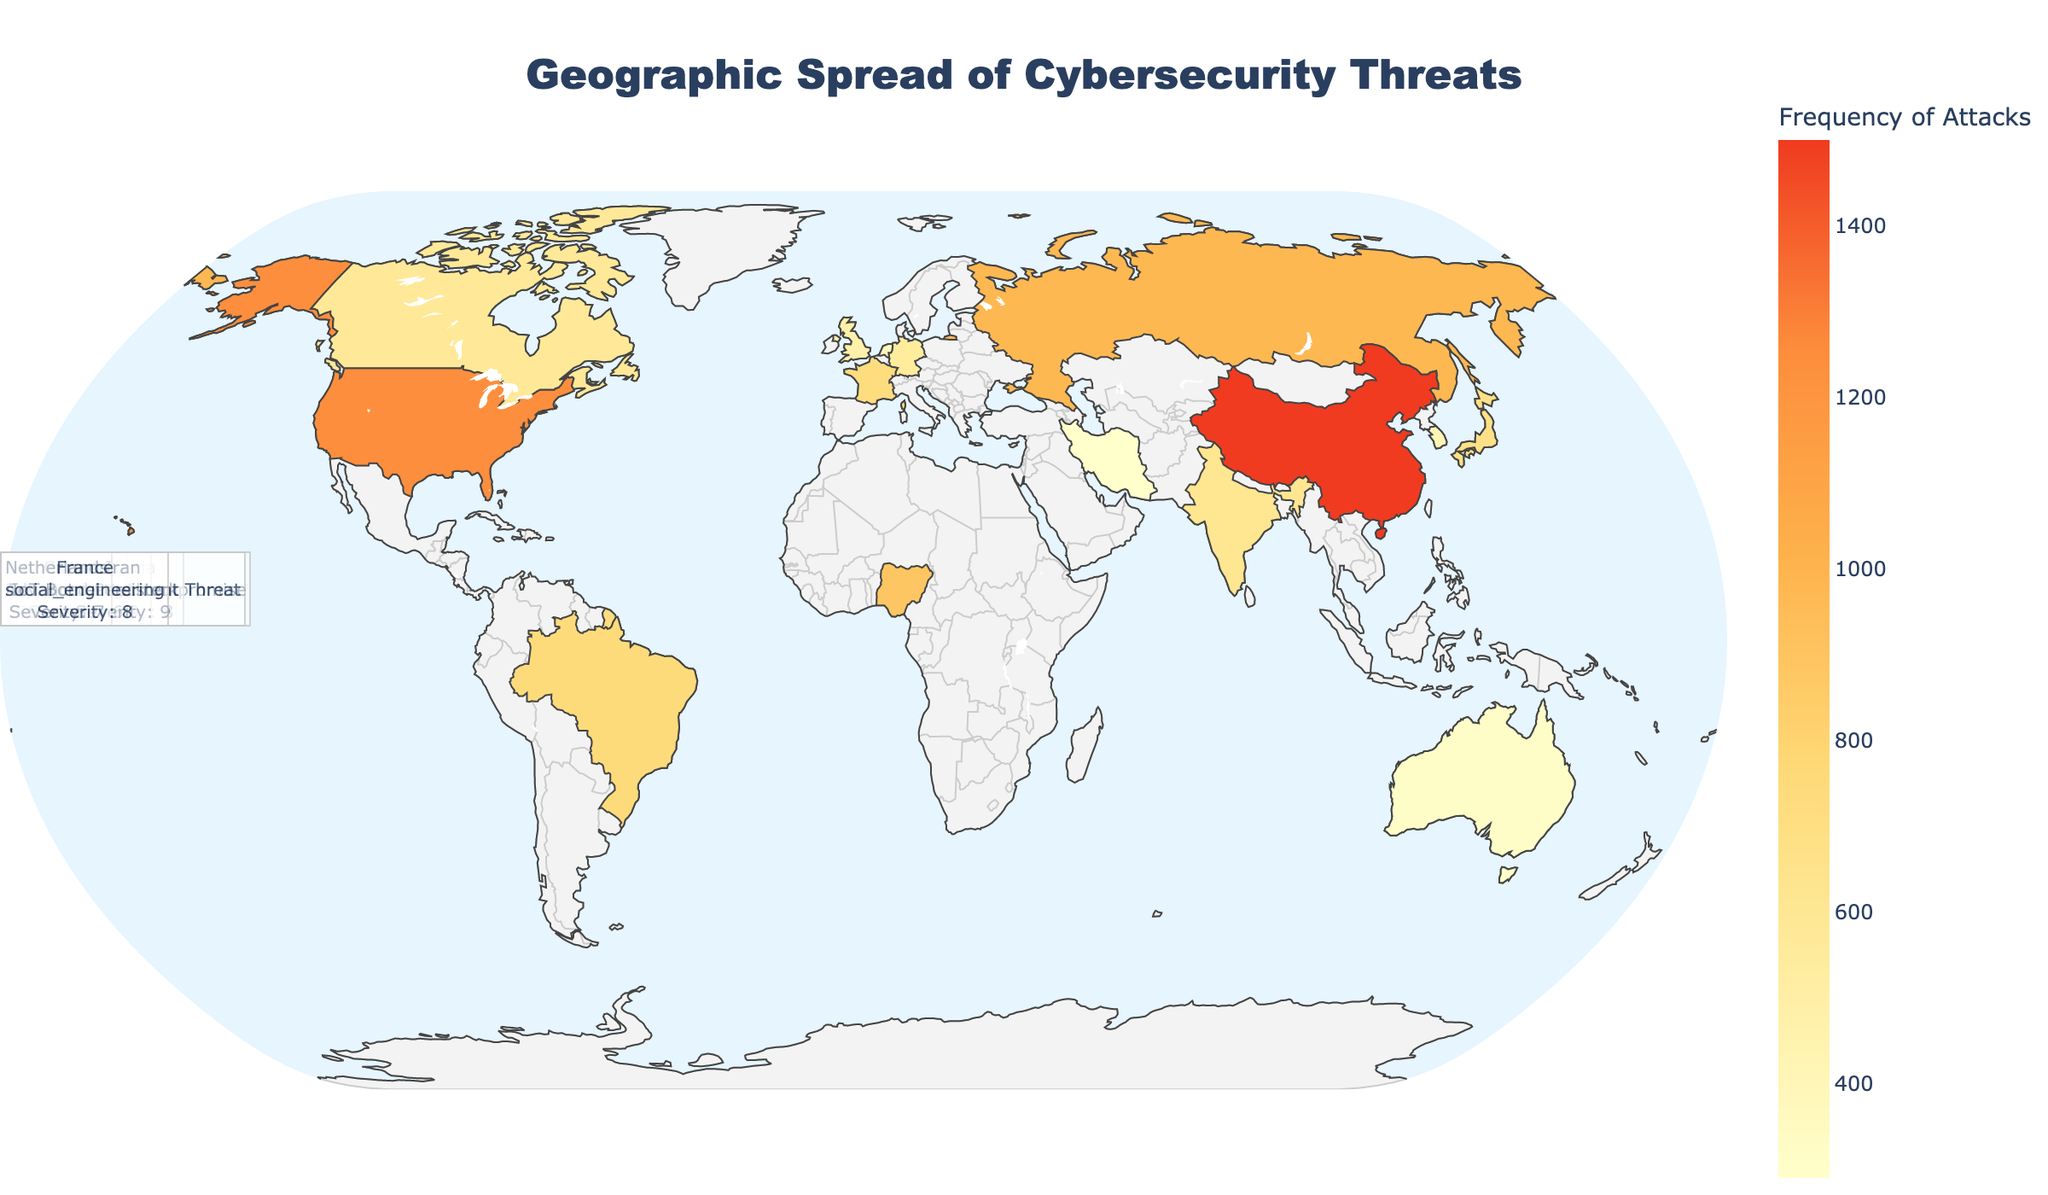What's the most common cybersecurity threat in the United States? The annotated text for the United States indicates "Ransomware" and shows color intensity signifying high frequencies, solidifying it as the most common threat.
Answer: Ransomware Which country shows the highest frequency of phishing attacks? By looking at the frequency of cybersecurity threats marked by intensity and the additional hover information, China has the highest frequency recorded for phishing attacks.
Answer: China How severe are ransomware attacks in the United States compared to social engineering attacks in France? The severity annotation indicates a severity of 8 for ransomware in the US and 8 for social engineering in France.
Answer: Equal severity What is the average severity level of the attacks labeled in the figure? Add the severity levels for all countries and divide by the number of countries: (8 + 7 + 6 + 5 + 6 + 9 + 7 + 5 + 8 + 9 + 4 + 6 + 9 + 7 + 8)/15 = 104/15.
Answer: 6.93 Which country has the lowest frequency of a cybersecurity threat, and what is the type of the attack? By checking the color intensity scale and identifying the lowest, Iran shows the lowest frequency, and the type is Advanced Persistent Threat.
Answer: Iran, Advanced Persistent Threat Compare the severity of cryptojacking attacks in South Korea to password attacks in Canada. Which is higher? From the annotations, cryptojacking in South Korea has a severity of 4, while password attacks in Canada have a severity of 6.
Answer: Password attacks in Canada What is the total number of countries represented in the plot? By counting the number of unique country annotations visible in the plot, there are 15 countries shown.
Answer: 15 Which country facing DDoS attacks shows the highest severity? The figure shows only Russia with DDoS attacks and its severity marked as 7.
Answer: Russia Are zero-day exploit attacks more severe than cross-site scripting attacks based on the plot? According to the annotations, zero-day exploit attacks in the UK have a severity of 9, whereas cross-site scripting in Japan has a severity of 5.
Answer: Yes, zero-day exploit Identify the country with the highest severity of attack and specify the type of attack. Checking all severity ratings, the highest severity of 9 is marked for both the UK (Zero-day Exploit), Australia (Supply Chain Attack), and Iran (Advanced Persistent Threat).
Answer: UK, Australia, Iran 